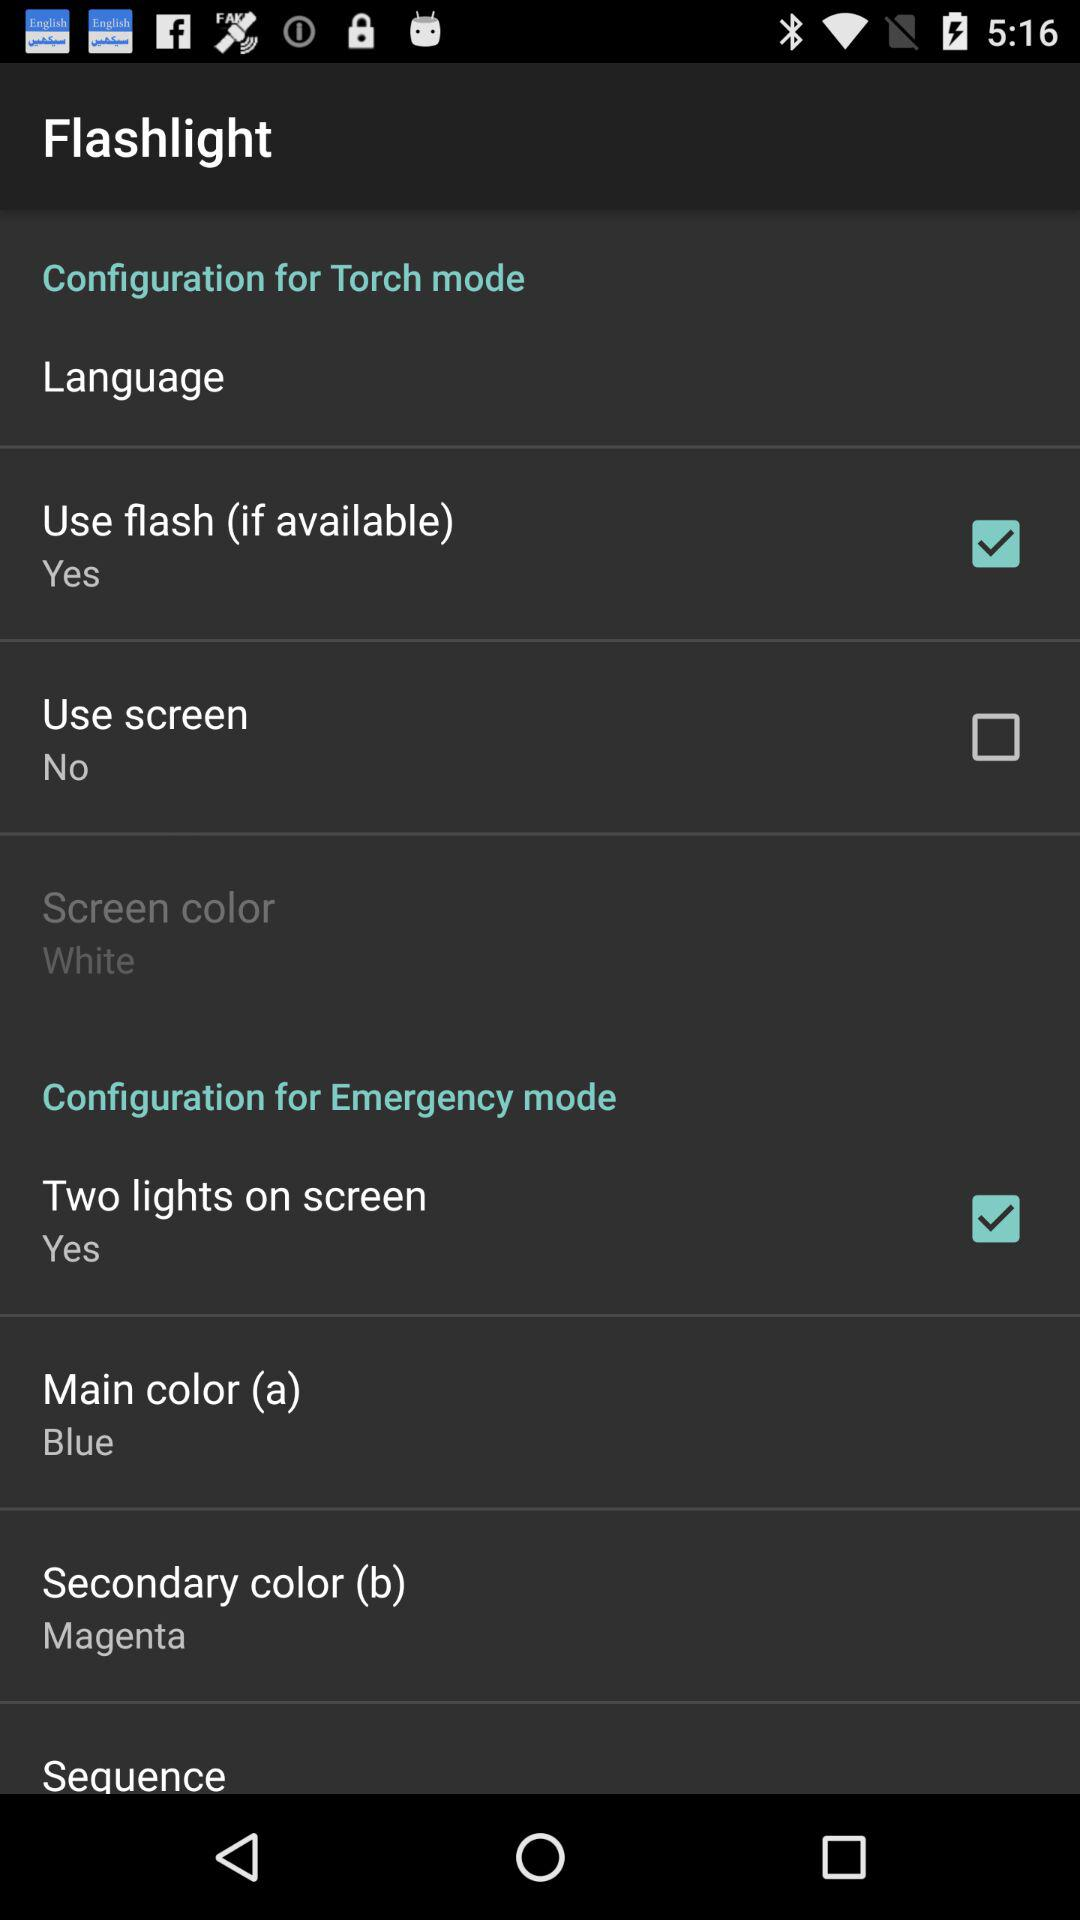Is "Use screen" checked or unchecked? "Use screen" is unchecked. 